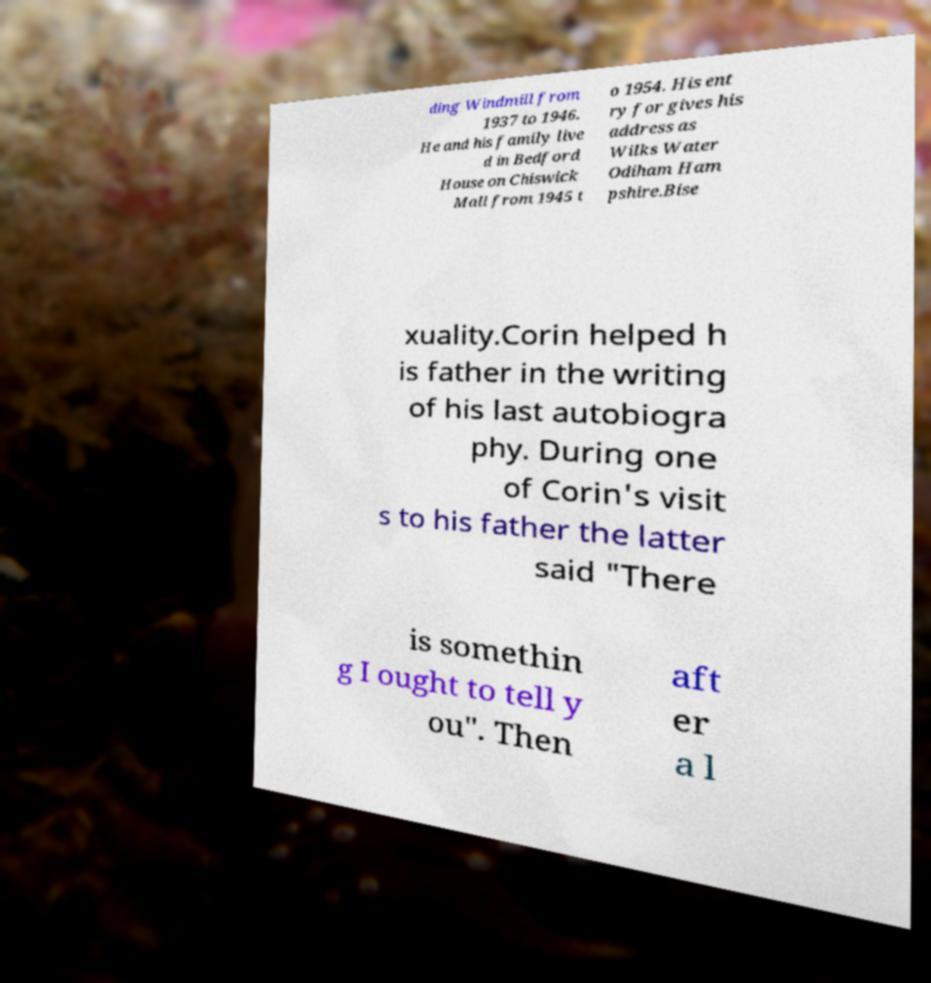For documentation purposes, I need the text within this image transcribed. Could you provide that? ding Windmill from 1937 to 1946. He and his family live d in Bedford House on Chiswick Mall from 1945 t o 1954. His ent ry for gives his address as Wilks Water Odiham Ham pshire.Bise xuality.Corin helped h is father in the writing of his last autobiogra phy. During one of Corin's visit s to his father the latter said "There is somethin g I ought to tell y ou". Then aft er a l 